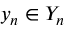<formula> <loc_0><loc_0><loc_500><loc_500>y _ { n } \in Y _ { n }</formula> 